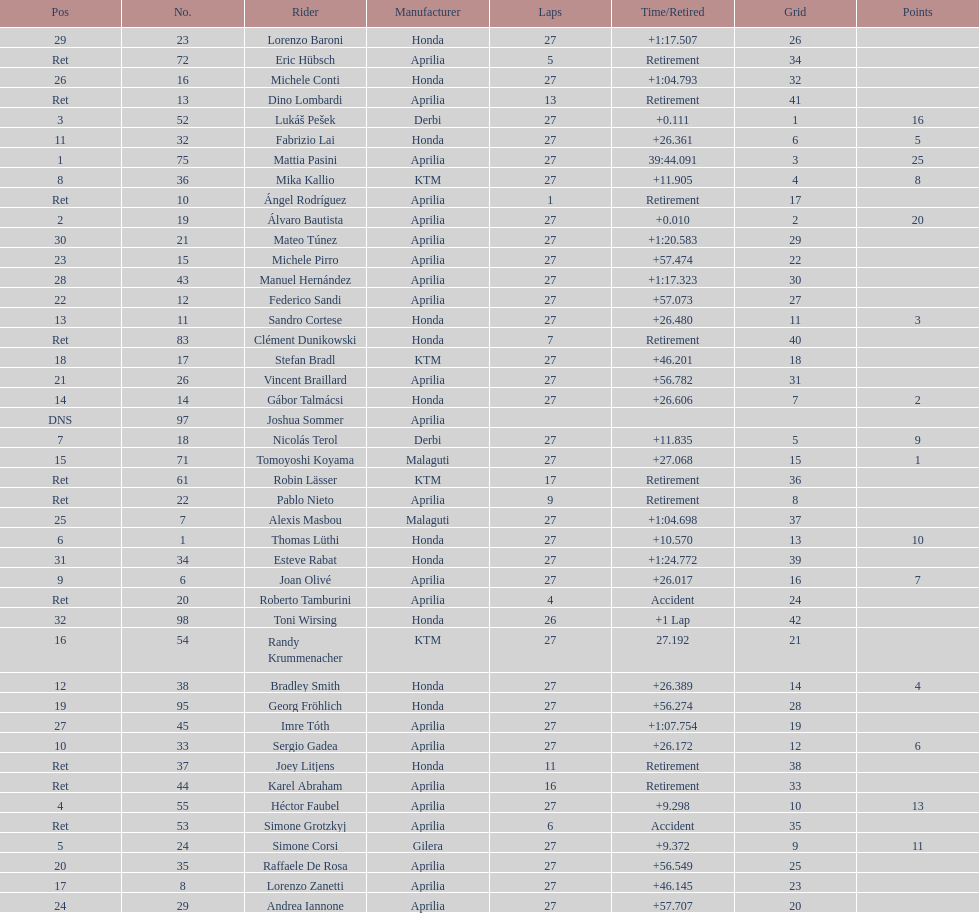Which rider secured first place with 25 points? Mattia Pasini. 